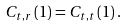Convert formula to latex. <formula><loc_0><loc_0><loc_500><loc_500>C _ { t , r } \left ( 1 \right ) = C _ { t , t } \left ( 1 \right ) .</formula> 